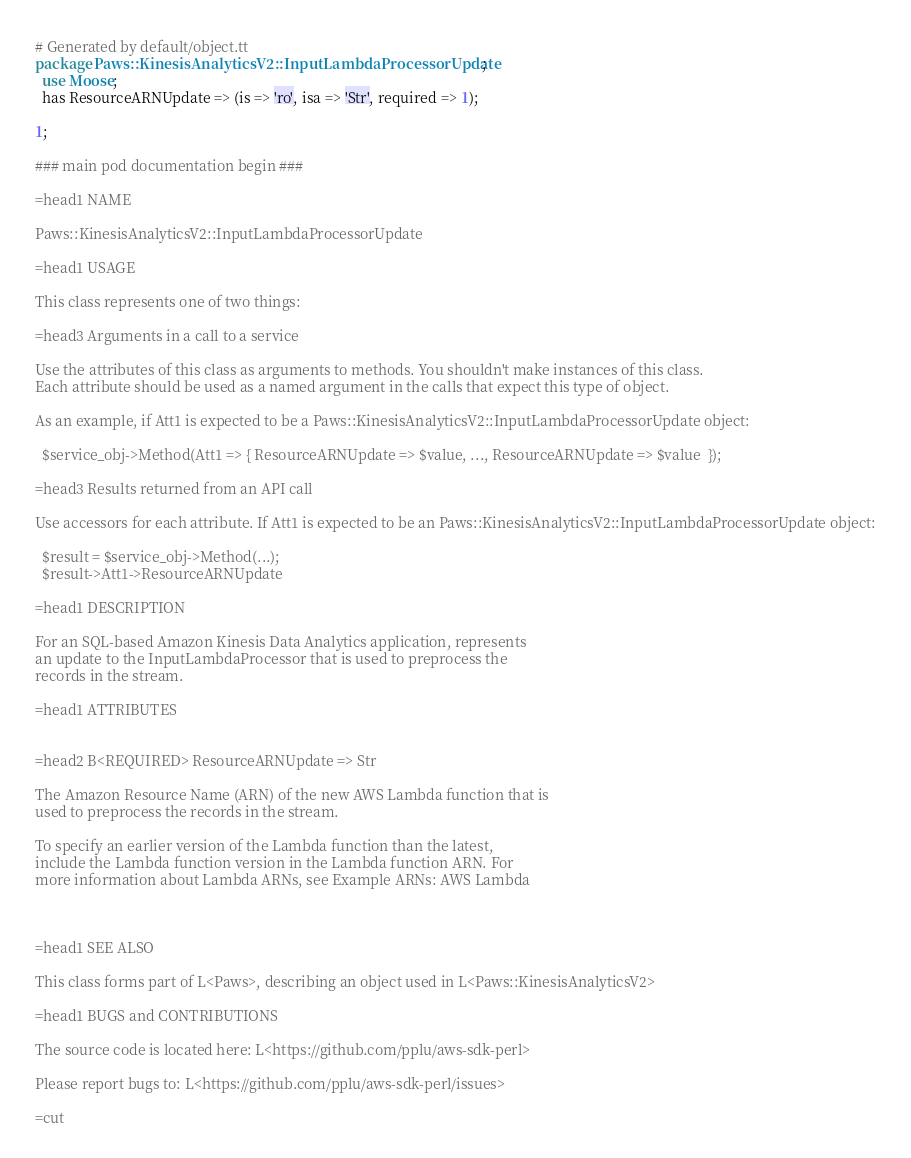Convert code to text. <code><loc_0><loc_0><loc_500><loc_500><_Perl_># Generated by default/object.tt
package Paws::KinesisAnalyticsV2::InputLambdaProcessorUpdate;
  use Moose;
  has ResourceARNUpdate => (is => 'ro', isa => 'Str', required => 1);

1;

### main pod documentation begin ###

=head1 NAME

Paws::KinesisAnalyticsV2::InputLambdaProcessorUpdate

=head1 USAGE

This class represents one of two things:

=head3 Arguments in a call to a service

Use the attributes of this class as arguments to methods. You shouldn't make instances of this class. 
Each attribute should be used as a named argument in the calls that expect this type of object.

As an example, if Att1 is expected to be a Paws::KinesisAnalyticsV2::InputLambdaProcessorUpdate object:

  $service_obj->Method(Att1 => { ResourceARNUpdate => $value, ..., ResourceARNUpdate => $value  });

=head3 Results returned from an API call

Use accessors for each attribute. If Att1 is expected to be an Paws::KinesisAnalyticsV2::InputLambdaProcessorUpdate object:

  $result = $service_obj->Method(...);
  $result->Att1->ResourceARNUpdate

=head1 DESCRIPTION

For an SQL-based Amazon Kinesis Data Analytics application, represents
an update to the InputLambdaProcessor that is used to preprocess the
records in the stream.

=head1 ATTRIBUTES


=head2 B<REQUIRED> ResourceARNUpdate => Str

The Amazon Resource Name (ARN) of the new AWS Lambda function that is
used to preprocess the records in the stream.

To specify an earlier version of the Lambda function than the latest,
include the Lambda function version in the Lambda function ARN. For
more information about Lambda ARNs, see Example ARNs: AWS Lambda



=head1 SEE ALSO

This class forms part of L<Paws>, describing an object used in L<Paws::KinesisAnalyticsV2>

=head1 BUGS and CONTRIBUTIONS

The source code is located here: L<https://github.com/pplu/aws-sdk-perl>

Please report bugs to: L<https://github.com/pplu/aws-sdk-perl/issues>

=cut

</code> 